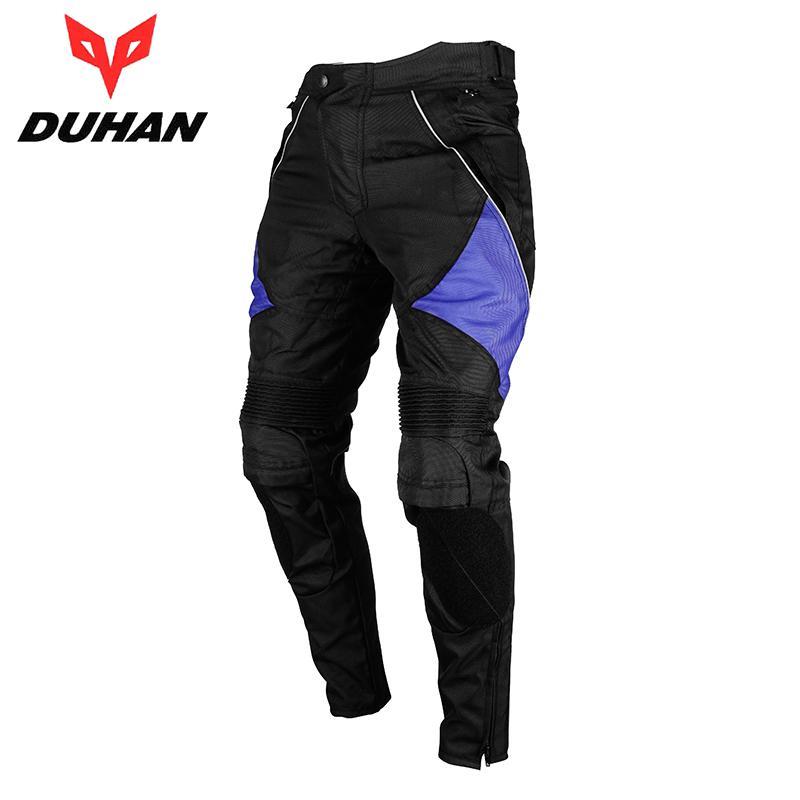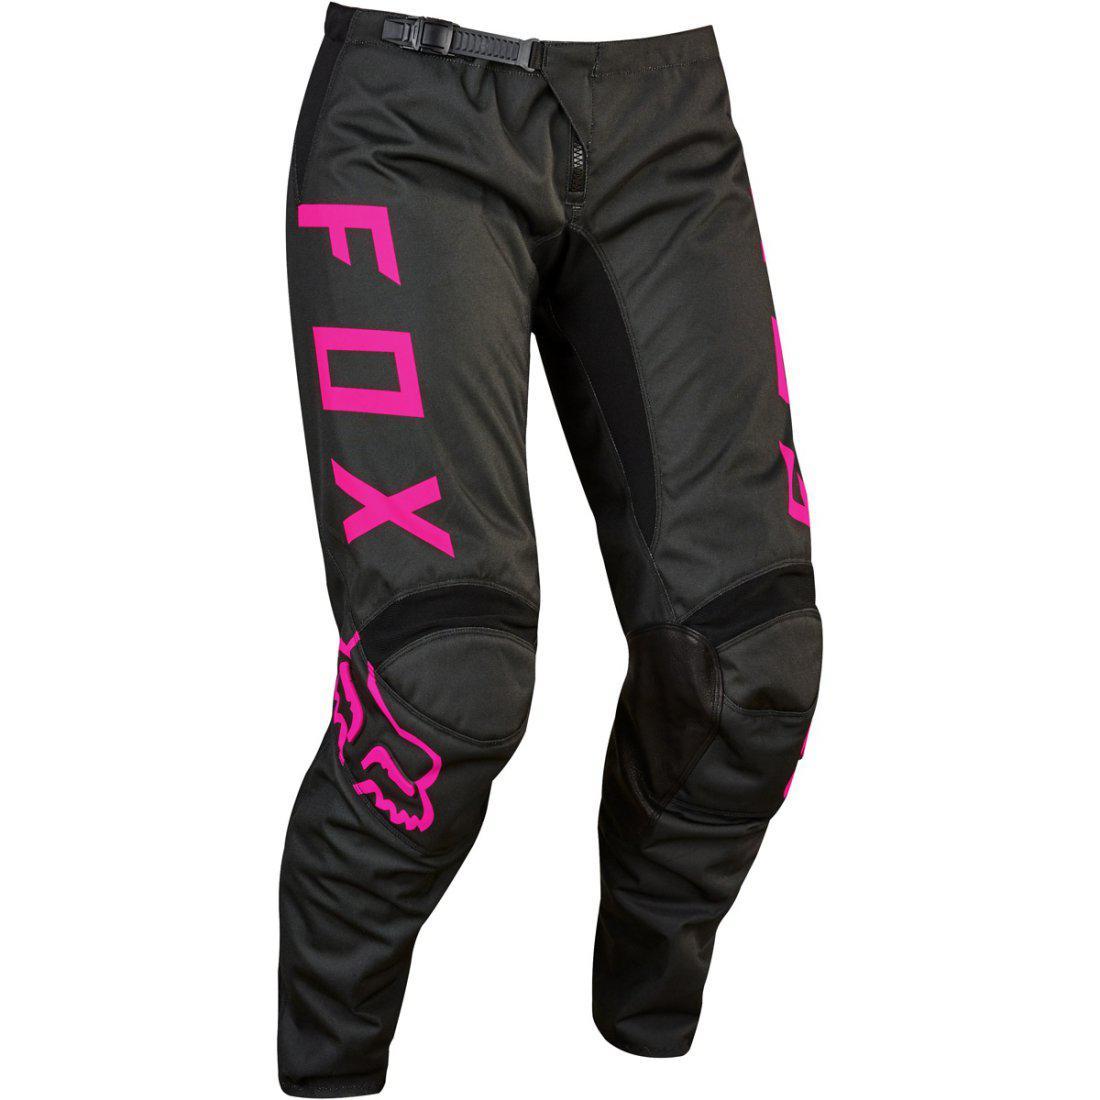The first image is the image on the left, the second image is the image on the right. Assess this claim about the two images: "there are full legged pants in the image pair". Correct or not? Answer yes or no. Yes. 